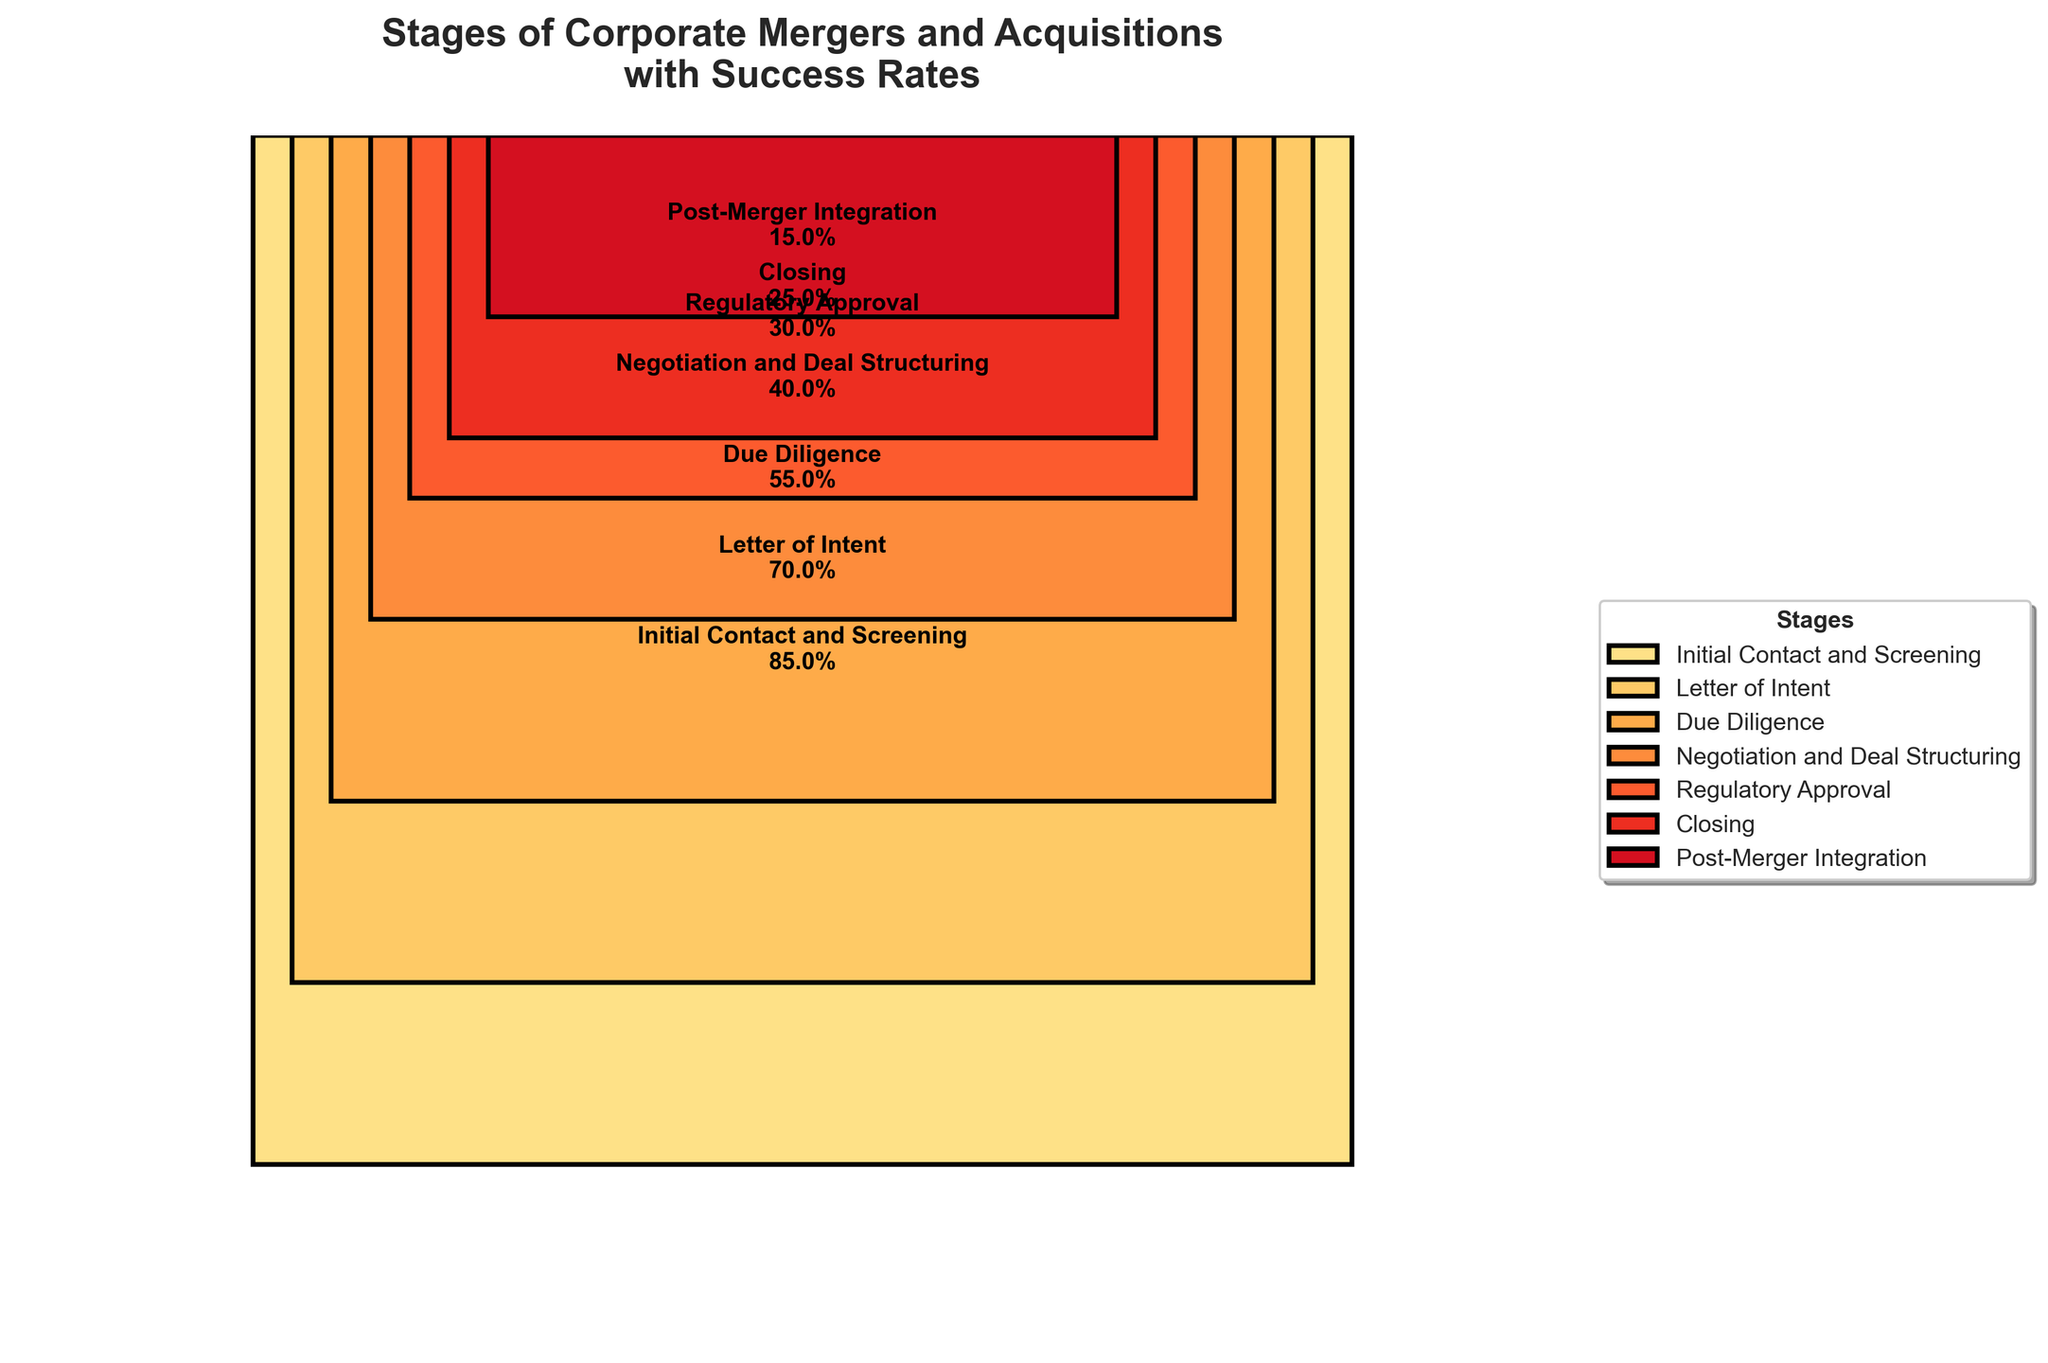What's the title of the figure? The figure's title is written at the top of the plot, summarizing its main theme.
Answer: Stages of Corporate Mergers and Acquisitions with Success Rates How many stages of corporate mergers and acquisitions are represented in the figure? Count the number of labeled stages shown on the plot.
Answer: Seven Which stage has the highest success rate? Observe the stage with the highest success rate indicated on the plot, which is the topmost bar.
Answer: Initial Contact and Screening By how much does the success rate decrease from the "Letter of Intent" stage to "Due Diligence"? Subtract the success rate of the "Due Diligence" stage from the "Letter of Intent" stage and compare the values.
Answer: 15% What is the difference in the success rate between the "Negotiation and Deal Structuring" stage and "Post-Merger Integration"? Subtract the success rate of "Post-Merger Integration" from "Negotiation and Deal Structuring" and compare the values.
Answer: 25% Which stage sees the steepest decrease in success rate compared to its previous stage? Compare the differences in success rates between consecutive stages and identify the largest decrease.
Answer: Due Diligence to Negotiation and Deal Structuring What is the average success rate across all stages? Add the success rates of all stages and divide by the number of stages to find the average. (Sum of rates: 85% + 70% + 55% + 40% + 30% + 25% + 15% = 320%, then divide by 7)
Answer: 45.71% What stage has the third highest success rate? Rank the stages by their success rates in descending order and identify the third one. (85%, 70%, 55%, 40%, 30%, 25%, 15%)
Answer: Due Diligence Which stages have a success rate below 50%? Identify all stages where the success rate is shown to be less than 50% on the plot.
Answer: Negotiation and Deal Structuring, Regulatory Approval, Closing, Post-Merger Integration Are there more stages with success rates above or below 50%? Count the number of stages with success rates above and below 50% and compare the two counts. (Above 50%: 3 stages, Below 50%: 4 stages)
Answer: Below 50% 